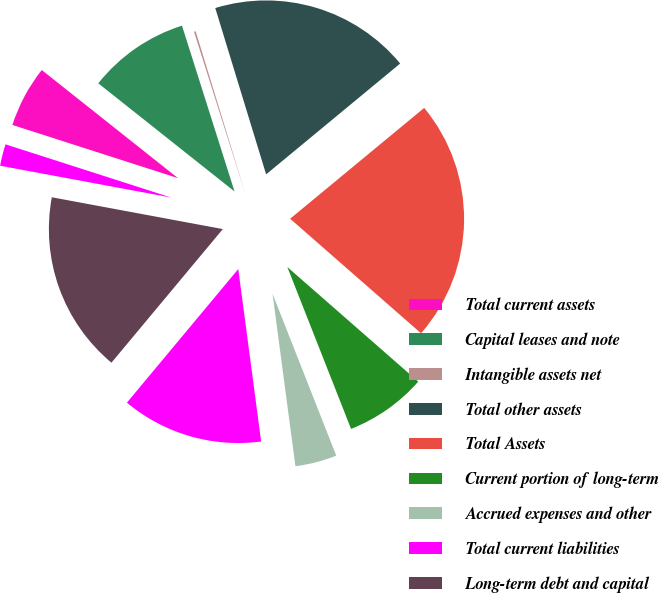<chart> <loc_0><loc_0><loc_500><loc_500><pie_chart><fcel>Total current assets<fcel>Capital leases and note<fcel>Intangible assets net<fcel>Total other assets<fcel>Total Assets<fcel>Current portion of long-term<fcel>Accrued expenses and other<fcel>Total current liabilities<fcel>Long-term debt and capital<fcel>Derivative instruments<nl><fcel>5.73%<fcel>9.44%<fcel>0.16%<fcel>18.73%<fcel>22.44%<fcel>7.59%<fcel>3.87%<fcel>13.16%<fcel>16.87%<fcel>2.02%<nl></chart> 